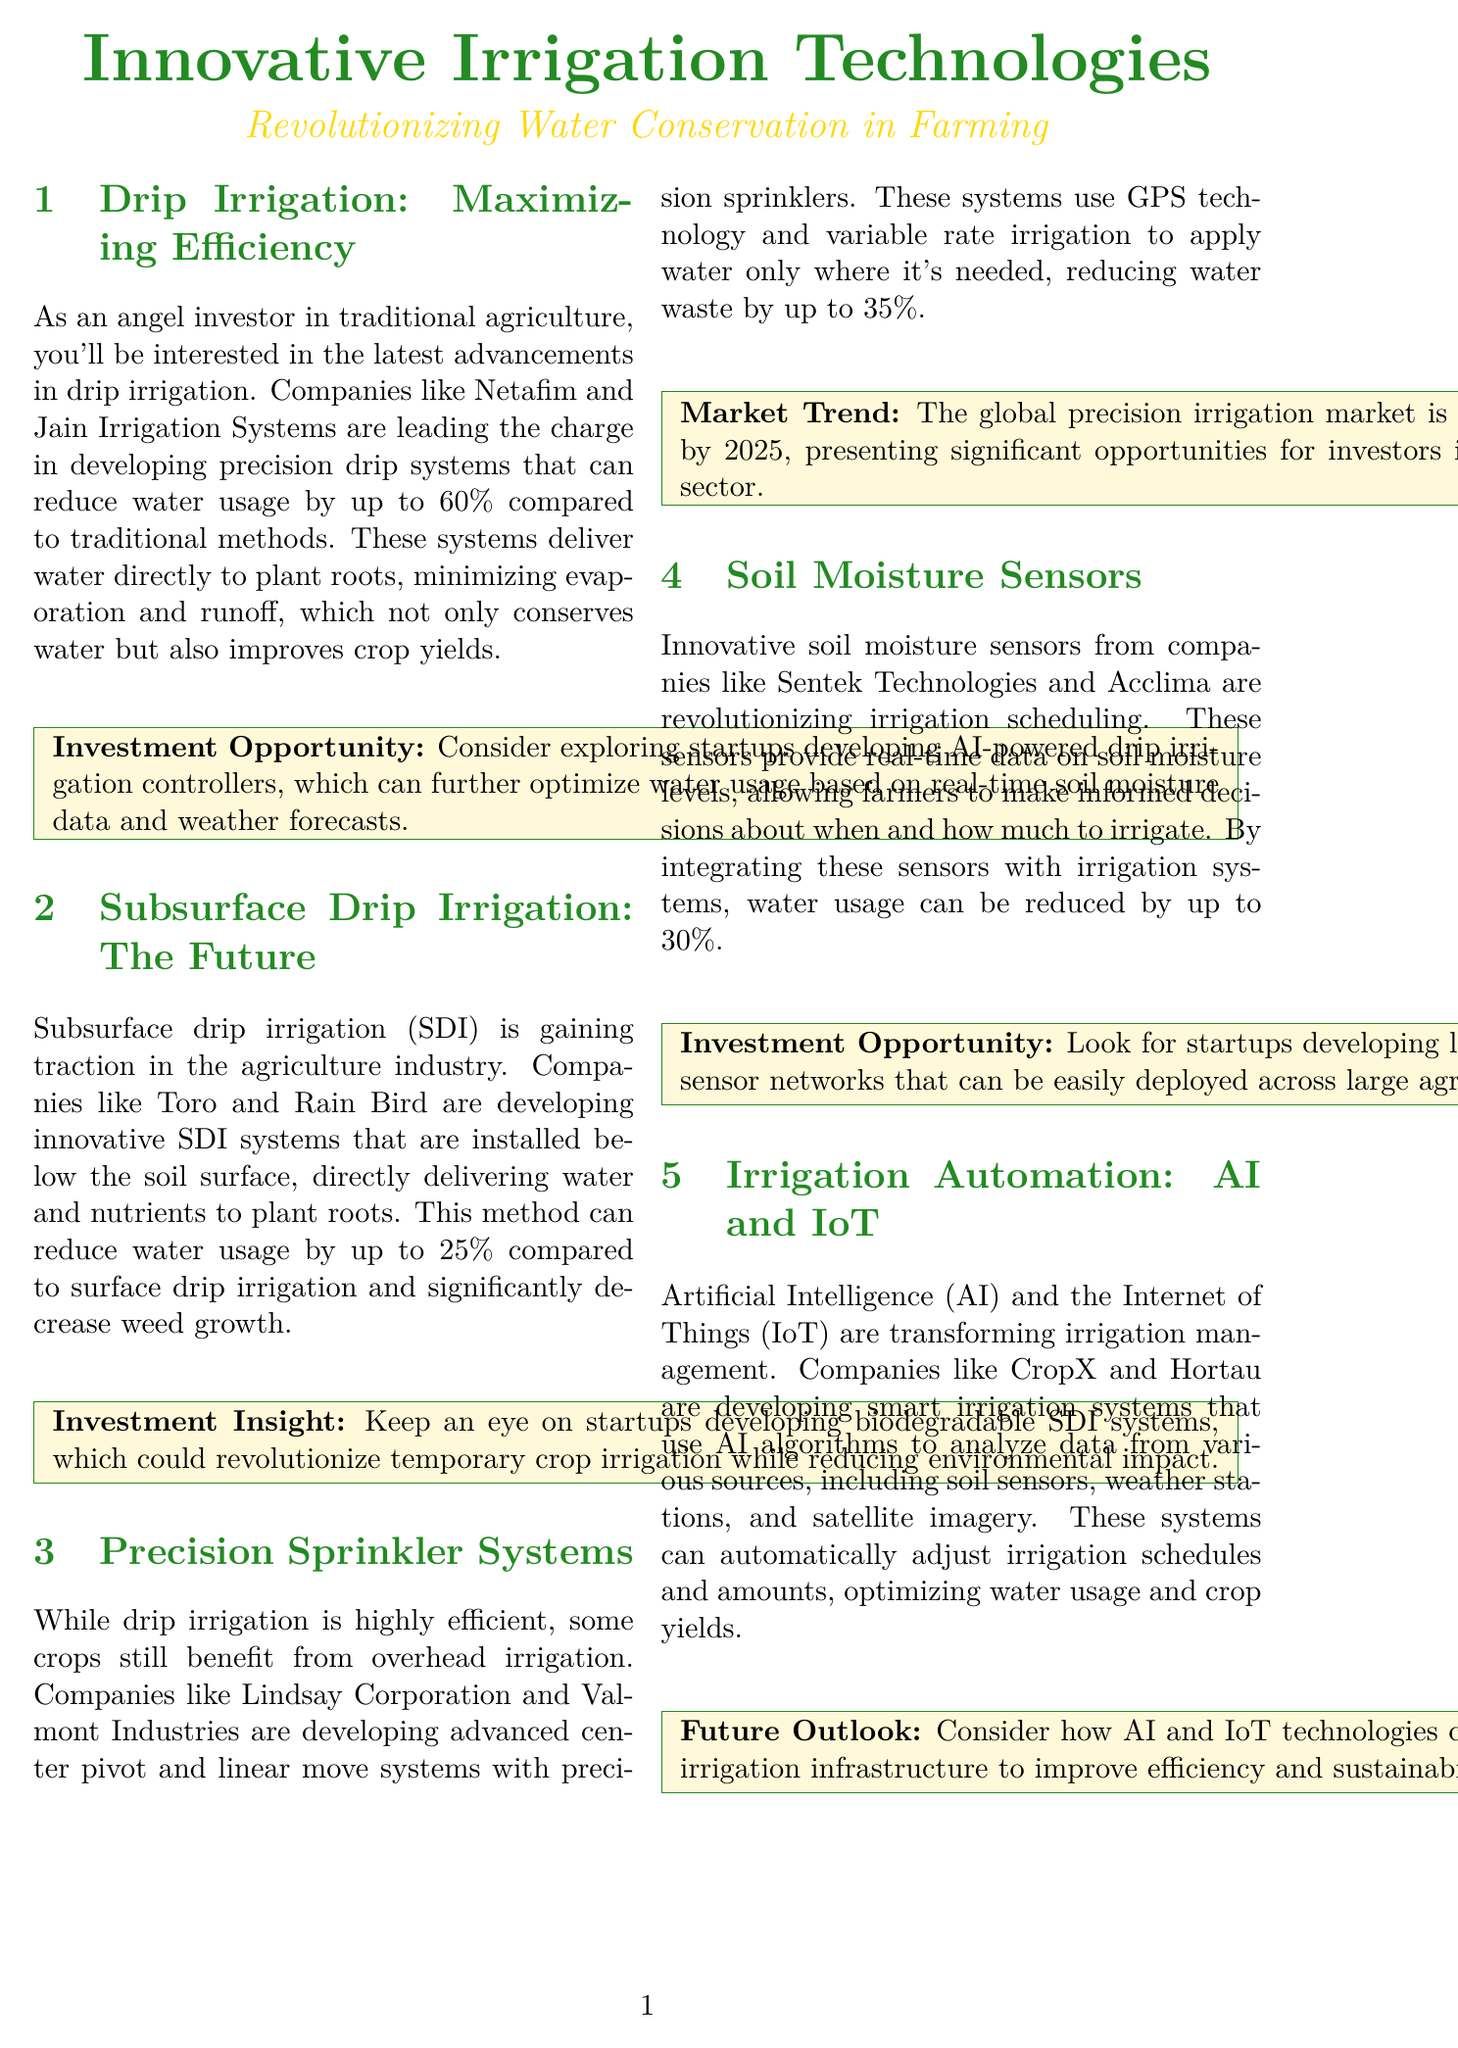What is the potential reduction in water usage with precision drip systems? Precision drip systems can reduce water usage by up to 60% compared to traditional methods.
Answer: 60% Which companies are developing biodegradable subsurface drip irrigation systems? The document suggests keeping an eye on startups developing biodegradable SDI systems, but does not name specific companies.
Answer: Startups What is the expected market size of the global precision irrigation market by 2025? The document states that the global precision irrigation market is expected to reach $9.5 billion by 2025.
Answer: $9.5 billion How much can water usage be reduced by integrating soil moisture sensors? By integrating soil moisture sensors with irrigation systems, water usage can be reduced by up to 30%.
Answer: 30% Which technologies are transforming irrigation management according to the document? The document mentions Artificial Intelligence (AI) and the Internet of Things (IoT) as technologies transforming irrigation management.
Answer: AI and IoT What is a key focus area for investment opportunities mentioned in the document? The document emphasizes exploring investment opportunities in startups developing low-cost, wireless soil moisture sensor networks.
Answer: Low-cost, wireless soil moisture sensors What is the primary benefit of subsurface drip irrigation compared to surface drip irrigation? Subsurface drip irrigation can reduce water usage by up to 25% compared to surface drip irrigation.
Answer: 25% Which two companies are mentioned as leaders in advanced center pivot systems? The document mentions Lindsay Corporation and Valmont Industries as leaders in this area.
Answer: Lindsay Corporation and Valmont Industries What is the overall message for angel investors regarding innovative irrigation technologies? The document encourages angel investors to explore innovative irrigation technologies that impact water conservation and crop yields.
Answer: Explore innovative irrigation technologies 